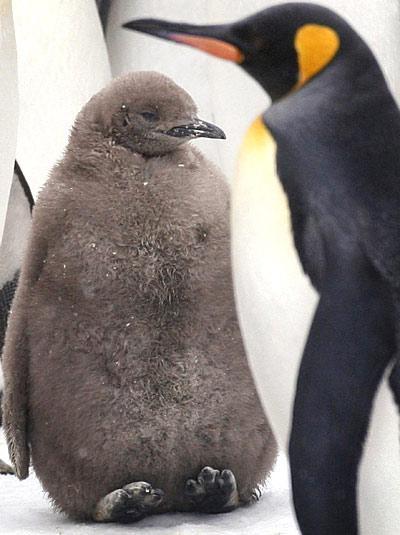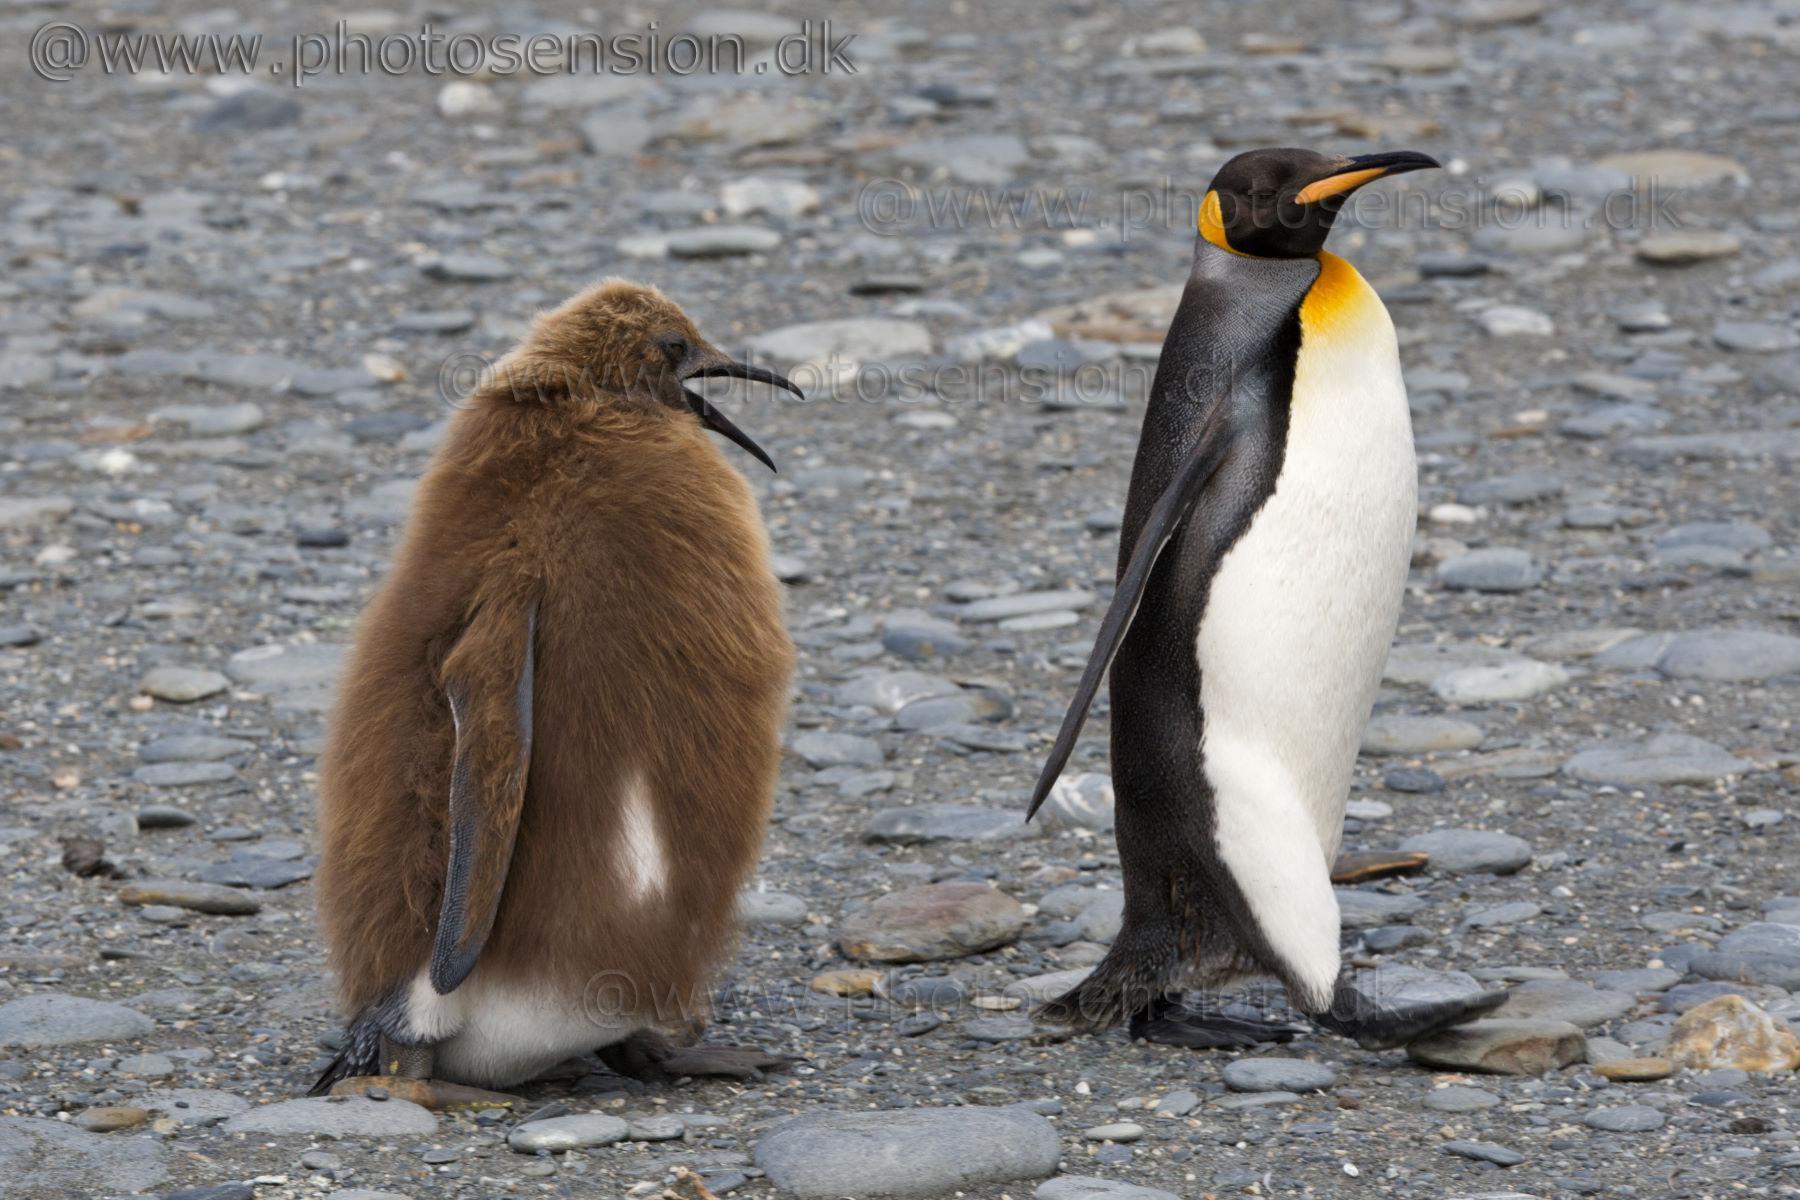The first image is the image on the left, the second image is the image on the right. Examine the images to the left and right. Is the description "In one of the photos, one of the penguins is brown, and in the other, none of the penguins are brown." accurate? Answer yes or no. No. 